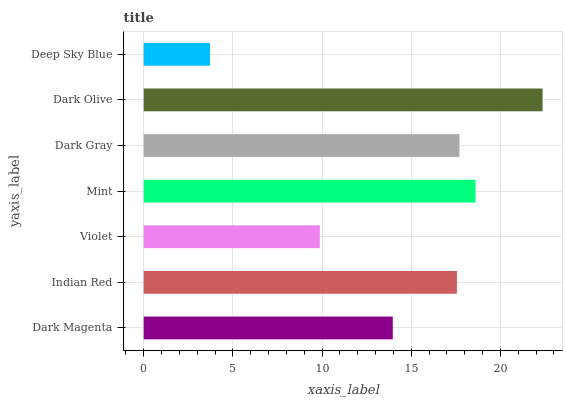Is Deep Sky Blue the minimum?
Answer yes or no. Yes. Is Dark Olive the maximum?
Answer yes or no. Yes. Is Indian Red the minimum?
Answer yes or no. No. Is Indian Red the maximum?
Answer yes or no. No. Is Indian Red greater than Dark Magenta?
Answer yes or no. Yes. Is Dark Magenta less than Indian Red?
Answer yes or no. Yes. Is Dark Magenta greater than Indian Red?
Answer yes or no. No. Is Indian Red less than Dark Magenta?
Answer yes or no. No. Is Indian Red the high median?
Answer yes or no. Yes. Is Indian Red the low median?
Answer yes or no. Yes. Is Violet the high median?
Answer yes or no. No. Is Dark Gray the low median?
Answer yes or no. No. 